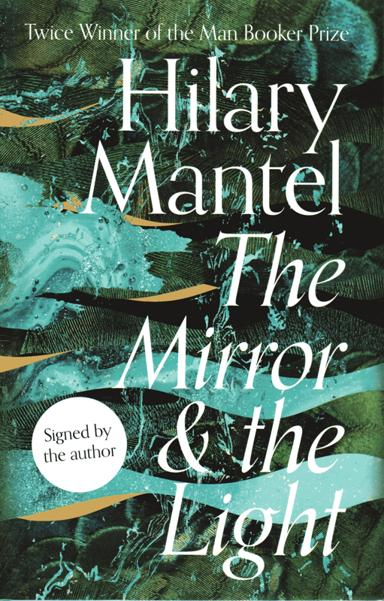How does the cover design of the book reflect its content? The turbulent, swirling patterns and dark, contrasting colors on the cover of 'The Mirror and the Light' suggest the tumultuous political intrigue and dense atmosphere of the Tudor court. The design captures the essence of a period marked by intense power struggles and pivotal historical events, mirroring the turmoil experienced by the characters. 